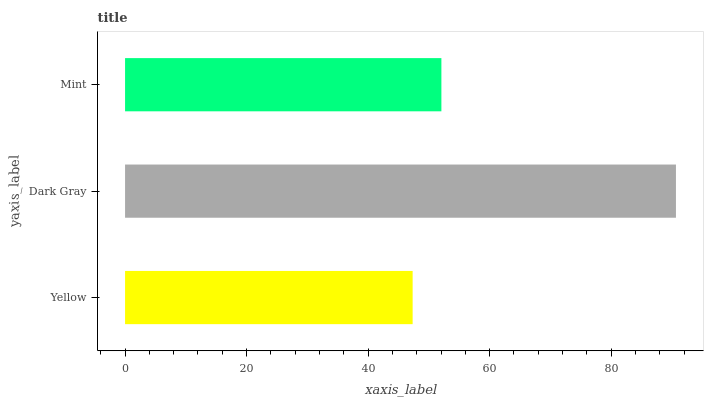Is Yellow the minimum?
Answer yes or no. Yes. Is Dark Gray the maximum?
Answer yes or no. Yes. Is Mint the minimum?
Answer yes or no. No. Is Mint the maximum?
Answer yes or no. No. Is Dark Gray greater than Mint?
Answer yes or no. Yes. Is Mint less than Dark Gray?
Answer yes or no. Yes. Is Mint greater than Dark Gray?
Answer yes or no. No. Is Dark Gray less than Mint?
Answer yes or no. No. Is Mint the high median?
Answer yes or no. Yes. Is Mint the low median?
Answer yes or no. Yes. Is Dark Gray the high median?
Answer yes or no. No. Is Dark Gray the low median?
Answer yes or no. No. 